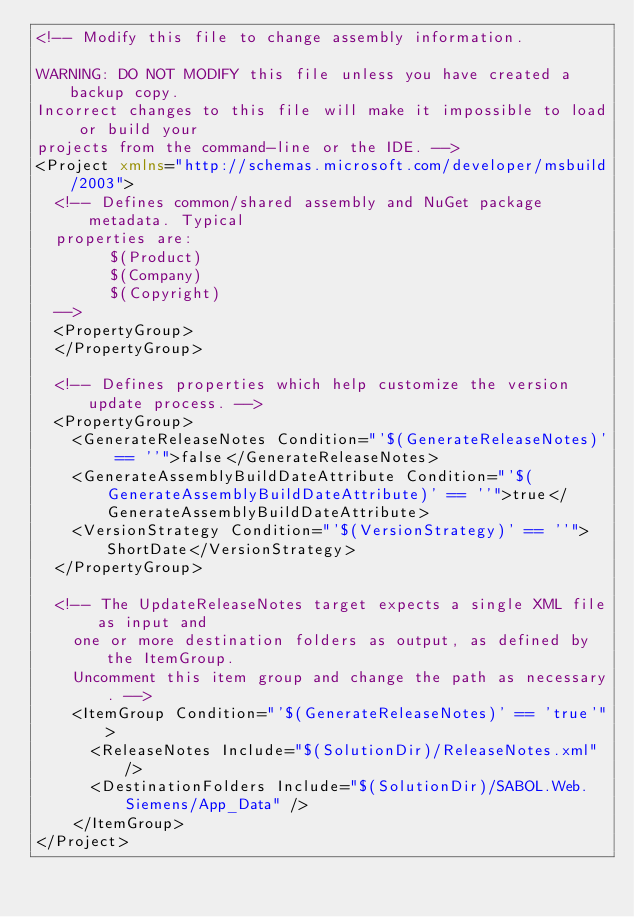<code> <loc_0><loc_0><loc_500><loc_500><_XML_><!-- Modify this file to change assembly information.

WARNING: DO NOT MODIFY this file unless you have created a backup copy.
Incorrect changes to this file will make it impossible to load or build your
projects from the command-line or the IDE. -->
<Project xmlns="http://schemas.microsoft.com/developer/msbuild/2003">
  <!-- Defines common/shared assembly and NuGet package metadata. Typical
  properties are:
        $(Product)
        $(Company)
        $(Copyright)
  -->
  <PropertyGroup>
  </PropertyGroup>

  <!-- Defines properties which help customize the version update process. -->
  <PropertyGroup>
    <GenerateReleaseNotes Condition="'$(GenerateReleaseNotes)' == ''">false</GenerateReleaseNotes>
    <GenerateAssemblyBuildDateAttribute Condition="'$(GenerateAssemblyBuildDateAttribute)' == ''">true</GenerateAssemblyBuildDateAttribute>
    <VersionStrategy Condition="'$(VersionStrategy)' == ''">ShortDate</VersionStrategy>
  </PropertyGroup>

  <!-- The UpdateReleaseNotes target expects a single XML file as input and
    one or more destination folders as output, as defined by the ItemGroup.
    Uncomment this item group and change the path as necessary. -->
    <ItemGroup Condition="'$(GenerateReleaseNotes)' == 'true'">
      <ReleaseNotes Include="$(SolutionDir)/ReleaseNotes.xml" />
      <DestinationFolders Include="$(SolutionDir)/SABOL.Web.Siemens/App_Data" />
    </ItemGroup>
</Project>
</code> 